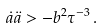Convert formula to latex. <formula><loc_0><loc_0><loc_500><loc_500>\dot { a } \ddot { a } > - b ^ { 2 } \tau ^ { - 3 } \, .</formula> 